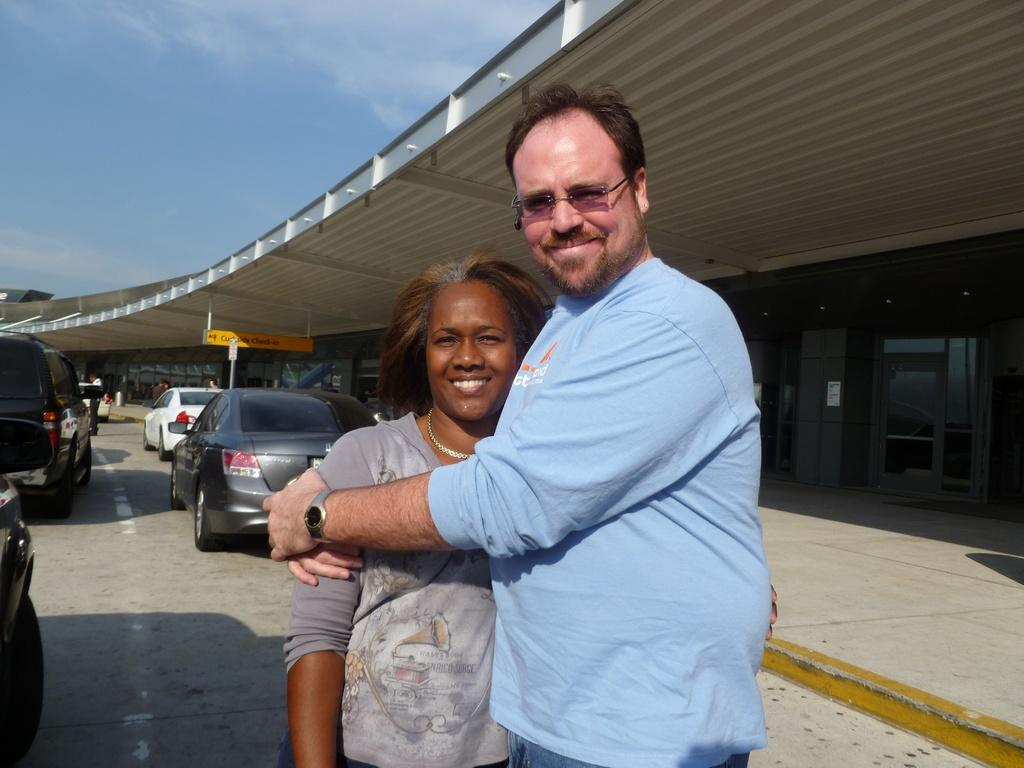How many people are present in the image? There is a man and a woman in the image. What can be seen in the background of the image? Cars and a building with a glass door are visible in the background of the image. What part of the natural environment is visible in the image? The sky is visible in the top left of the image. What is the price of the bat in the image? There is no bat present in the image, so it is not possible to determine its price. 